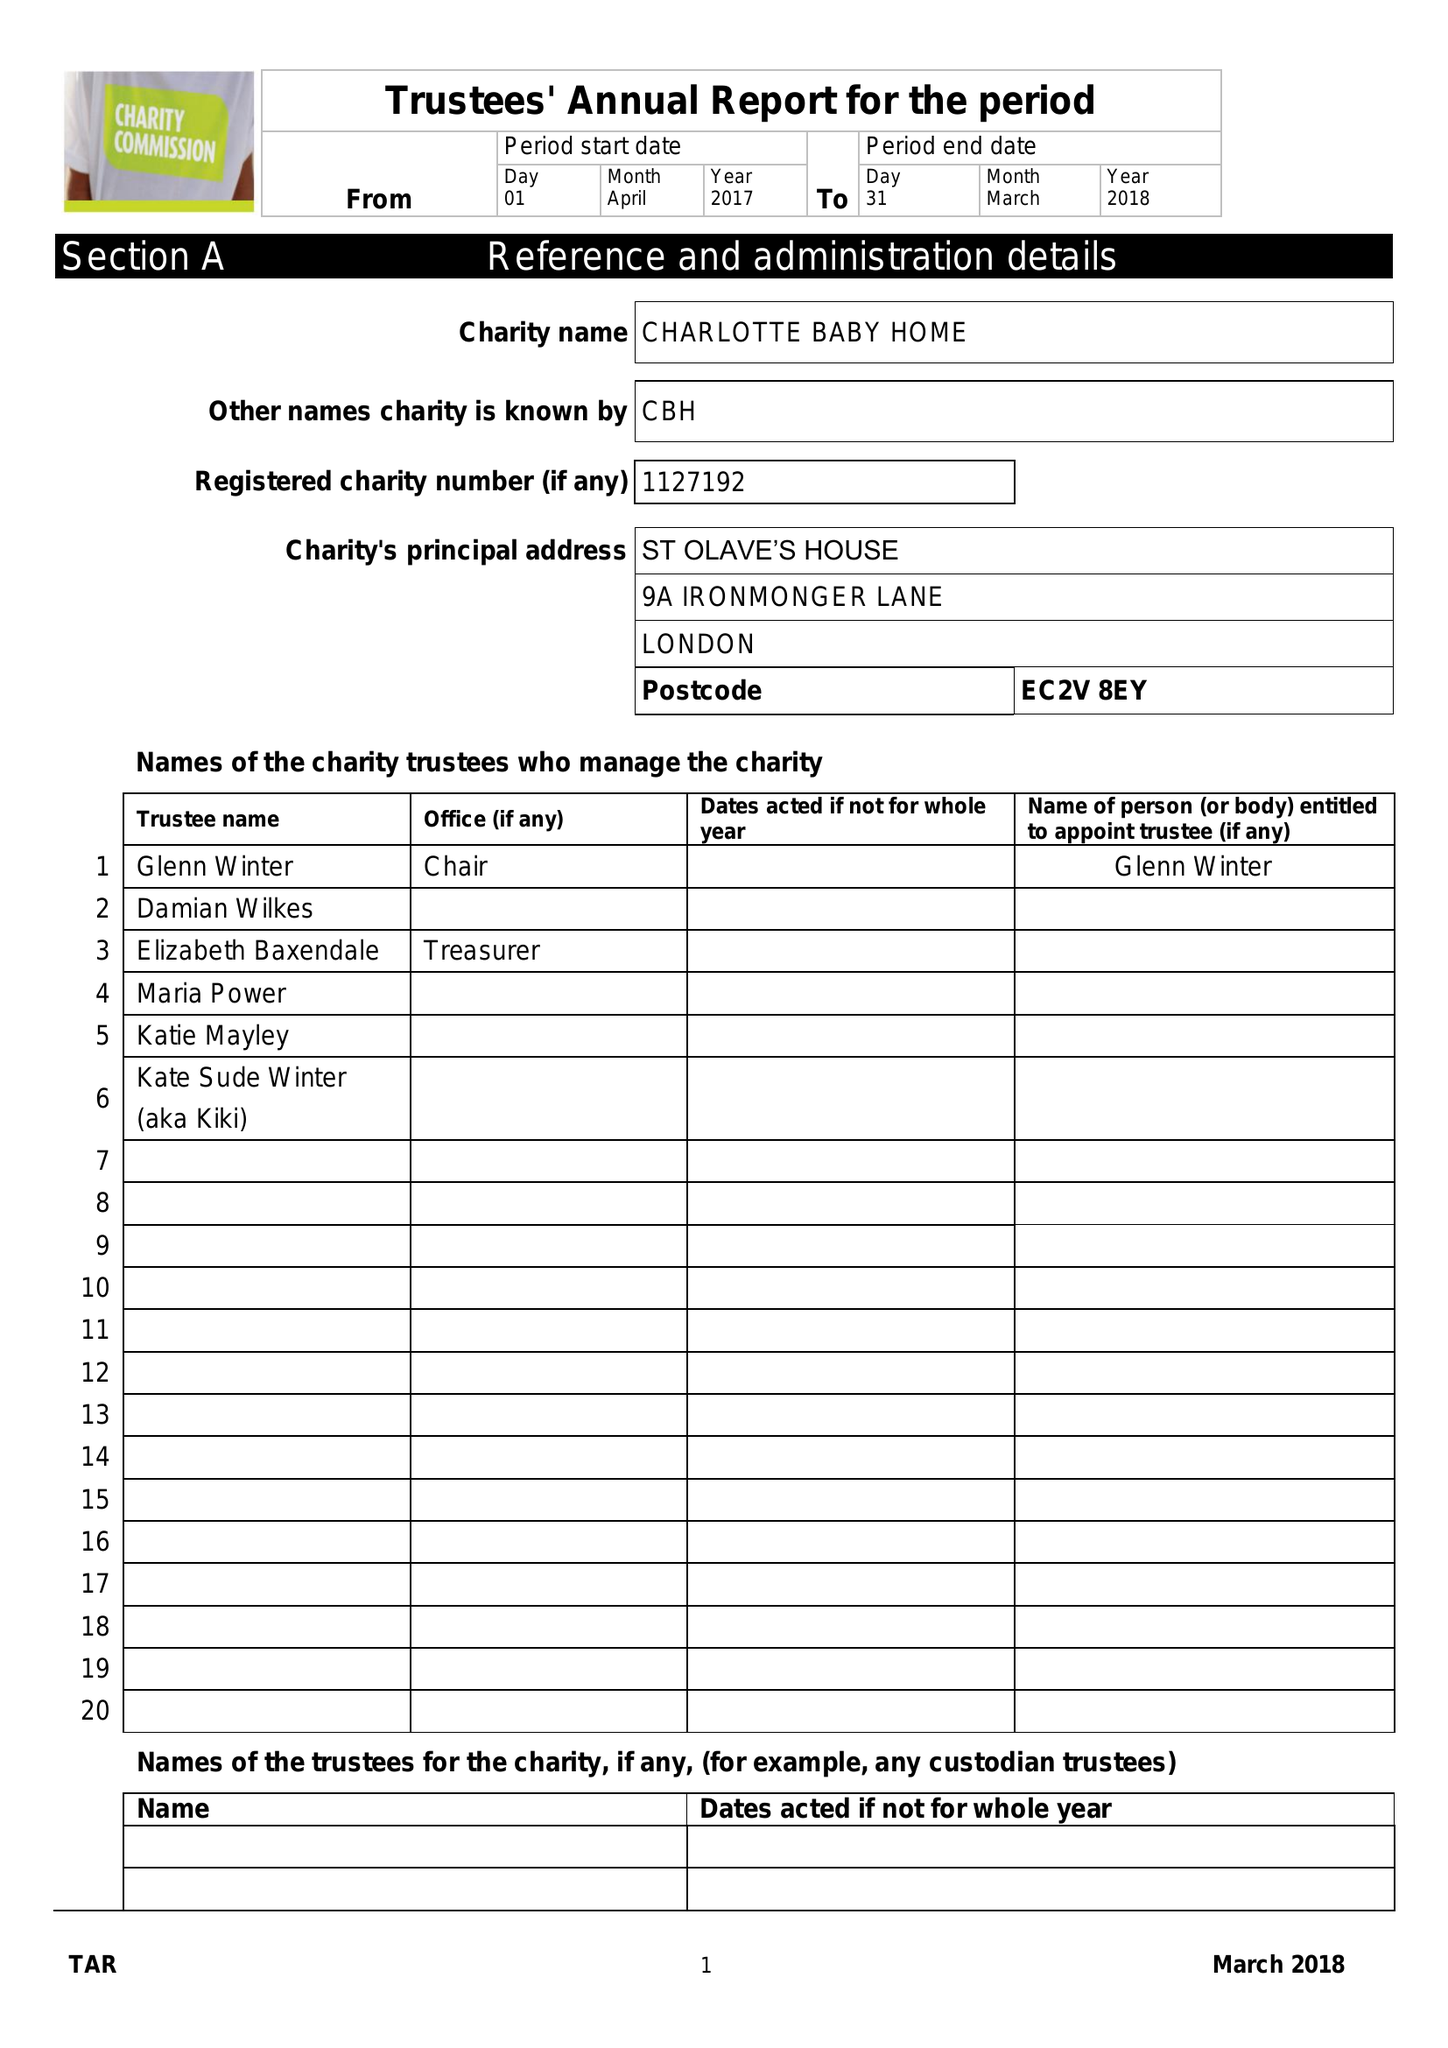What is the value for the report_date?
Answer the question using a single word or phrase. 2018-03-31 